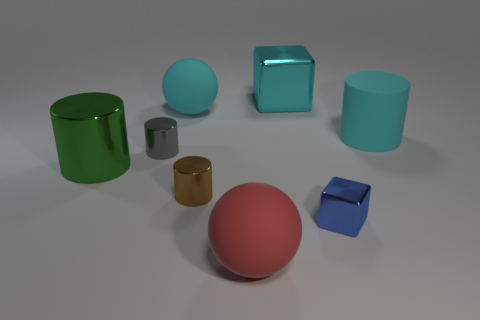Add 1 red rubber spheres. How many objects exist? 9 Subtract all cubes. How many objects are left? 6 Subtract all tiny brown shiny cylinders. Subtract all tiny gray shiny objects. How many objects are left? 6 Add 2 red spheres. How many red spheres are left? 3 Add 6 tiny blue metal objects. How many tiny blue metal objects exist? 7 Subtract 1 cyan cylinders. How many objects are left? 7 